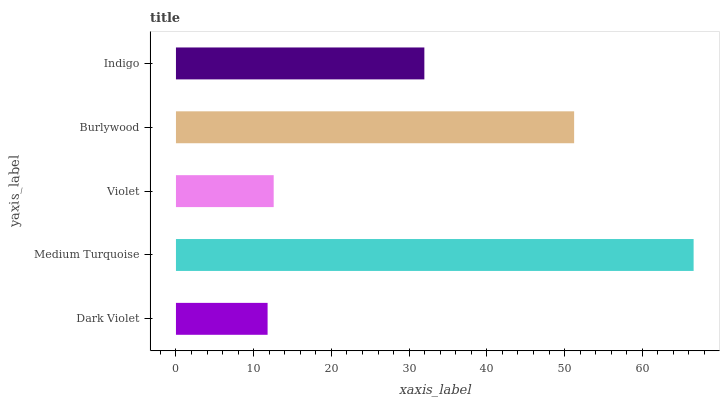Is Dark Violet the minimum?
Answer yes or no. Yes. Is Medium Turquoise the maximum?
Answer yes or no. Yes. Is Violet the minimum?
Answer yes or no. No. Is Violet the maximum?
Answer yes or no. No. Is Medium Turquoise greater than Violet?
Answer yes or no. Yes. Is Violet less than Medium Turquoise?
Answer yes or no. Yes. Is Violet greater than Medium Turquoise?
Answer yes or no. No. Is Medium Turquoise less than Violet?
Answer yes or no. No. Is Indigo the high median?
Answer yes or no. Yes. Is Indigo the low median?
Answer yes or no. Yes. Is Dark Violet the high median?
Answer yes or no. No. Is Medium Turquoise the low median?
Answer yes or no. No. 